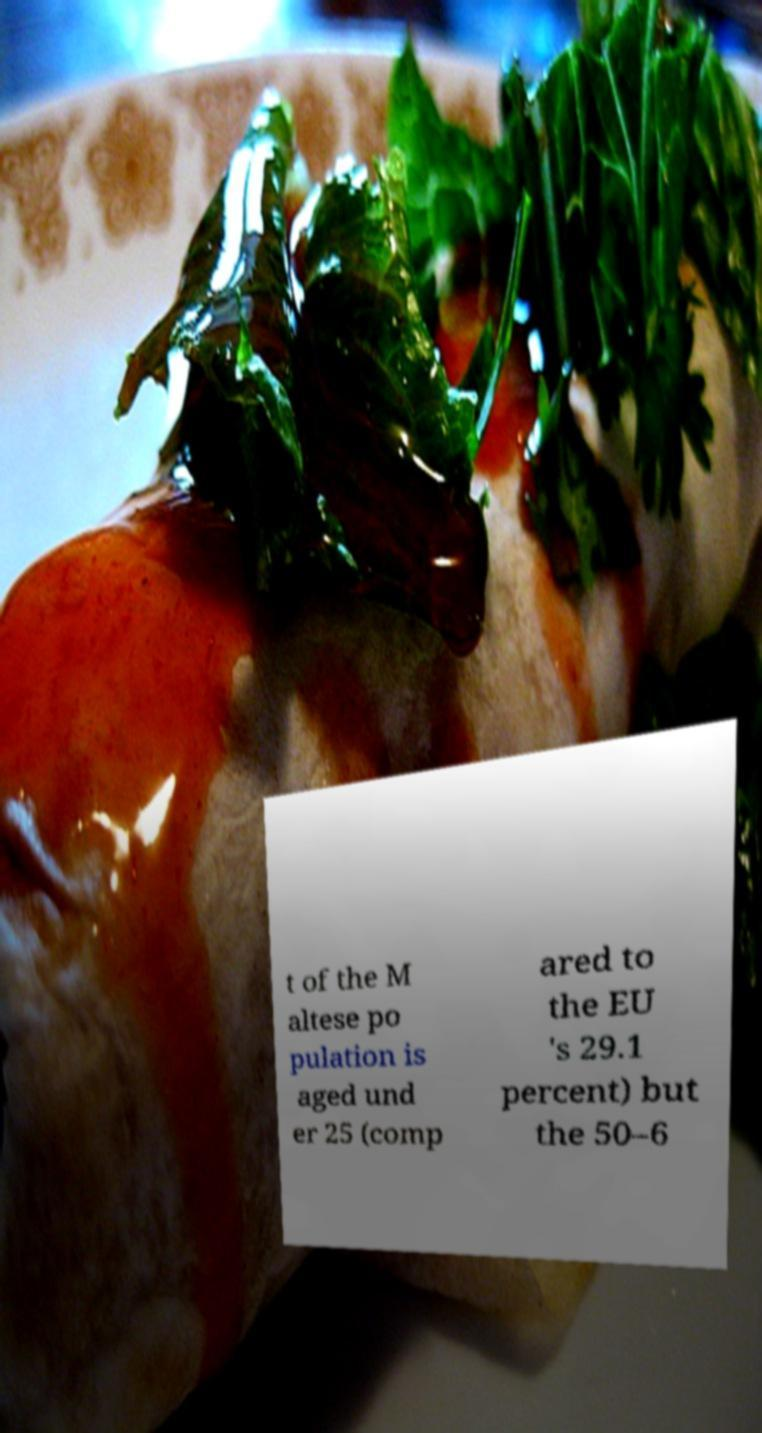For documentation purposes, I need the text within this image transcribed. Could you provide that? t of the M altese po pulation is aged und er 25 (comp ared to the EU 's 29.1 percent) but the 50–6 